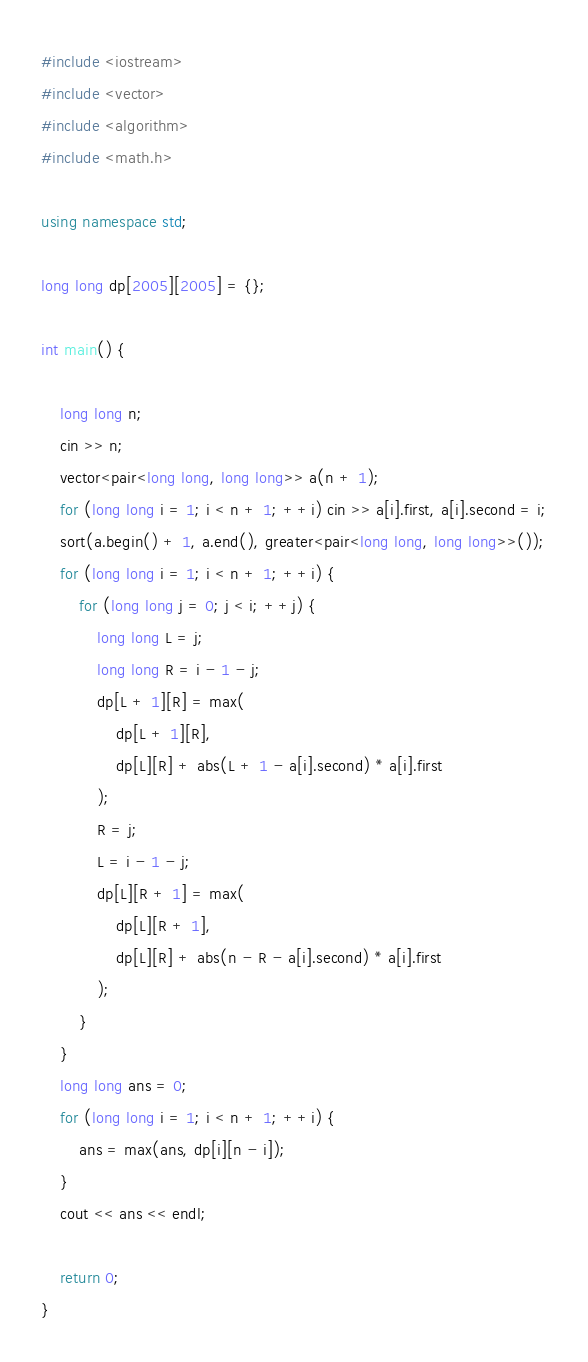<code> <loc_0><loc_0><loc_500><loc_500><_C++_>#include <iostream>
#include <vector>
#include <algorithm>
#include <math.h>

using namespace std;

long long dp[2005][2005] = {};

int main() {
    
    long long n;
    cin >> n;
    vector<pair<long long, long long>> a(n + 1);
    for (long long i = 1; i < n + 1; ++i) cin >> a[i].first, a[i].second = i;
    sort(a.begin() + 1, a.end(), greater<pair<long long, long long>>());
    for (long long i = 1; i < n + 1; ++i) {
        for (long long j = 0; j < i; ++j) {
            long long L = j;
            long long R = i - 1 - j;
            dp[L + 1][R] = max(
                dp[L + 1][R],
                dp[L][R] + abs(L + 1 - a[i].second) * a[i].first
            );
            R = j;
            L = i - 1 - j;
            dp[L][R + 1] = max(
                dp[L][R + 1],
                dp[L][R] + abs(n - R - a[i].second) * a[i].first
            );
        }
    }
    long long ans = 0;
    for (long long i = 1; i < n + 1; ++i) {
        ans = max(ans, dp[i][n - i]);
    }
    cout << ans << endl;

    return 0;
}</code> 